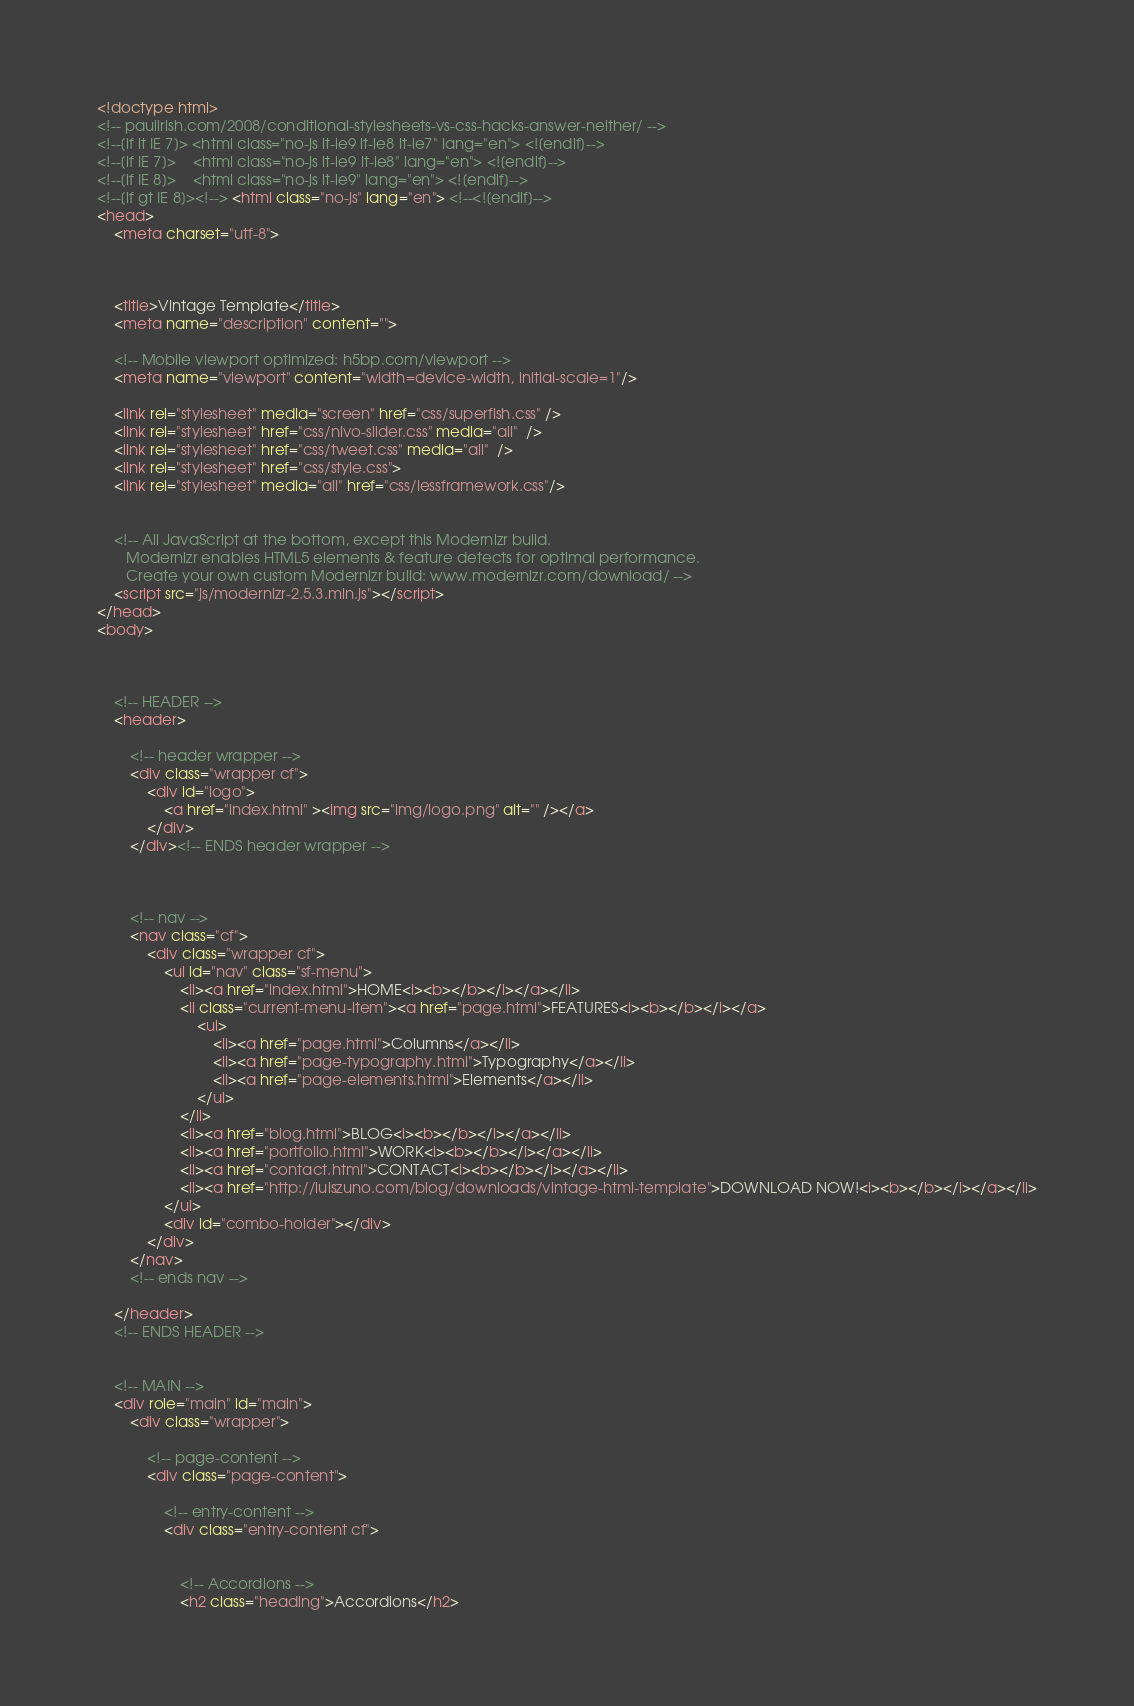<code> <loc_0><loc_0><loc_500><loc_500><_HTML_><!doctype html>
<!-- paulirish.com/2008/conditional-stylesheets-vs-css-hacks-answer-neither/ -->
<!--[if lt IE 7]> <html class="no-js lt-ie9 lt-ie8 lt-ie7" lang="en"> <![endif]-->
<!--[if IE 7]>    <html class="no-js lt-ie9 lt-ie8" lang="en"> <![endif]-->
<!--[if IE 8]>    <html class="no-js lt-ie9" lang="en"> <![endif]-->
<!--[if gt IE 8]><!--> <html class="no-js" lang="en"> <!--<![endif]-->
<head>
	<meta charset="utf-8">
	
	
	
	<title>Vintage Template</title>
	<meta name="description" content="">
	
	<!-- Mobile viewport optimized: h5bp.com/viewport -->
	<meta name="viewport" content="width=device-width, initial-scale=1"/>
	
	<link rel="stylesheet" media="screen" href="css/superfish.css" /> 
	<link rel="stylesheet" href="css/nivo-slider.css" media="all"  /> 
	<link rel="stylesheet" href="css/tweet.css" media="all"  />
	<link rel="stylesheet" href="css/style.css">
	<link rel="stylesheet" media="all" href="css/lessframework.css"/>
	
	
	<!-- All JavaScript at the bottom, except this Modernizr build.
	   Modernizr enables HTML5 elements & feature detects for optimal performance.
	   Create your own custom Modernizr build: www.modernizr.com/download/ -->
	<script src="js/modernizr-2.5.3.min.js"></script>
</head>
<body>



	<!-- HEADER -->
	<header>
		
		<!-- header wrapper -->
		<div class="wrapper cf">
			<div id="logo">
				<a href="index.html" ><img src="img/logo.png" alt="" /></a>
			</div>
		</div><!-- ENDS header wrapper -->
		
		
		
		<!-- nav -->
		<nav class="cf">
			<div class="wrapper cf">
				<ul id="nav" class="sf-menu">
					<li><a href="index.html">HOME<i><b></b></i></a></li>
					<li class="current-menu-item"><a href="page.html">FEATURES<i><b></b></i></a>
						<ul>
							<li><a href="page.html">Columns</a></li>
							<li><a href="page-typography.html">Typography</a></li>
							<li><a href="page-elements.html">Elements</a></li>
						</ul>
					</li>
					<li><a href="blog.html">BLOG<i><b></b></i></a></li>
					<li><a href="portfolio.html">WORK<i><b></b></i></a></li>
					<li><a href="contact.html">CONTACT<i><b></b></i></a></li>
					<li><a href="http://luiszuno.com/blog/downloads/vintage-html-template">DOWNLOAD NOW!<i><b></b></i></a></li>
				</ul>
				<div id="combo-holder"></div>
			</div>
		</nav>
		<!-- ends nav -->
			
	</header>
	<!-- ENDS HEADER -->
	
	
	<!-- MAIN -->
	<div role="main" id="main">
		<div class="wrapper">
		
			<!-- page-content -->
			<div class="page-content">
				
				<!-- entry-content -->	
	        	<div class="entry-content cf">
	        		
					
				    <!-- Accordions -->
					<h2 class="heading">Accordions</h2></code> 